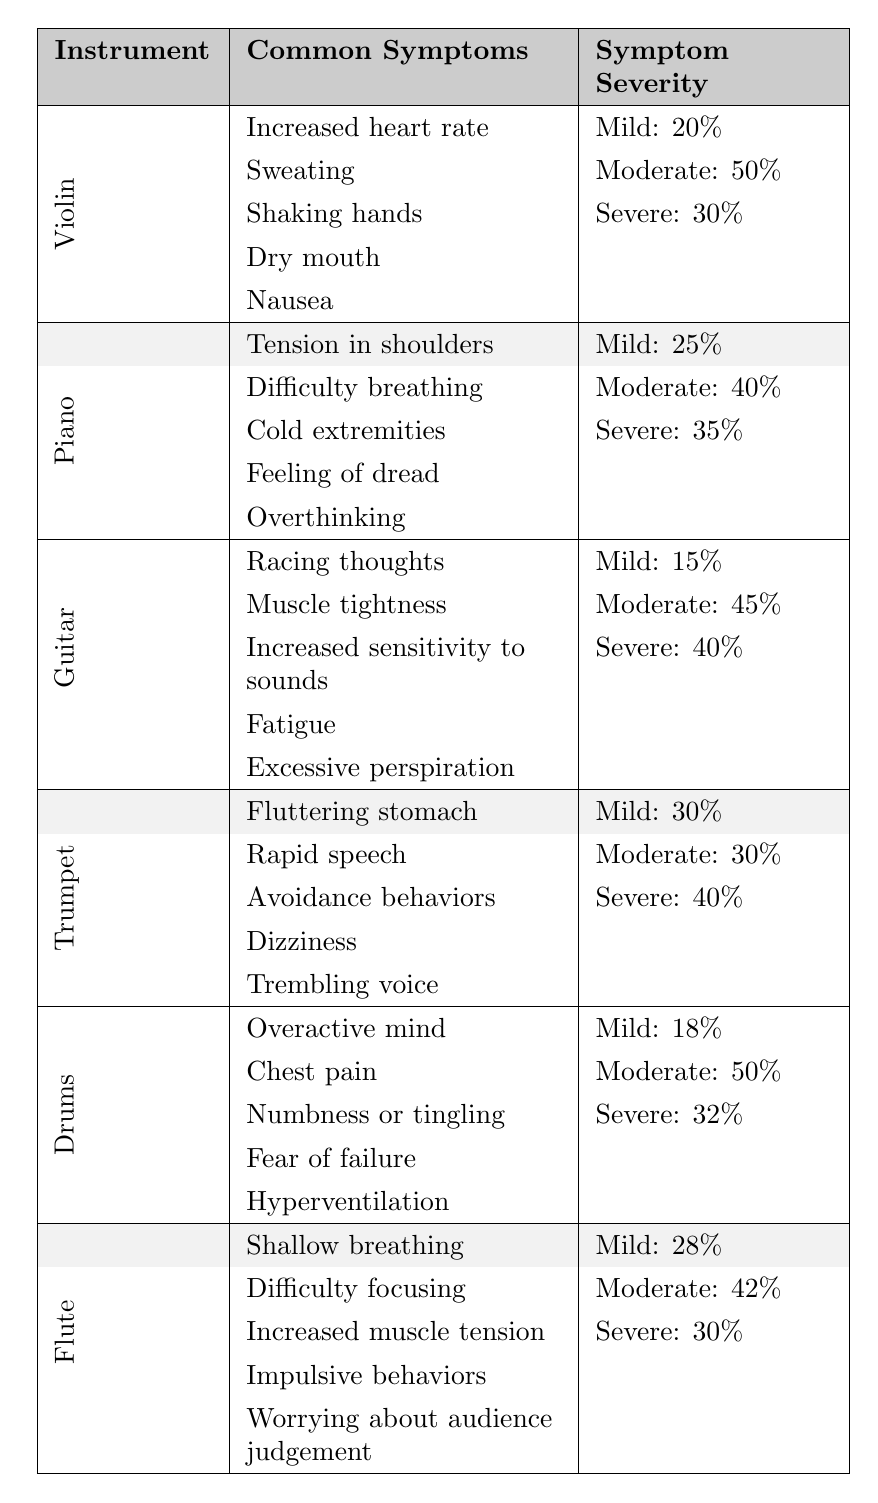What are the common symptoms of guitar players experiencing stage fright? Referring to the table, the symptoms listed for guitar players are racing thoughts, muscle tightness, increased sensitivity to sounds, fatigue, and excessive perspiration.
Answer: Racing thoughts, muscle tightness, increased sensitivity to sounds, fatigue, excessive perspiration Which instrument has the highest percentage of severe stage fright symptoms? By examining the severity data, trumpet, guitar, and drum players share severe symptoms with percentages of 40%, 40%, and 32% respectively, but trumpet has the highest among those listed, at 40%.
Answer: Trumpet How many different symptoms are reported for violin players? The table shows five symptoms listed under the violin category: increased heart rate, sweating, shaking hands, dry mouth, and nausea, indicating a total of five symptoms.
Answer: 5 Is it true that piano players report the least severe symptoms in comparison to other instruments? To determine this, we can compare the highest severe severity percentages of piano (35%) with the others: violin (30%), guitar (40%), trumpet (40%), drums (32%), and flute (30%). Piano does not report the least severe symptoms.
Answer: No What is the average percentage of mild symptoms reported across all instruments? To calculate the average, sum the mild percentages: 20 (violin) + 25 (piano) + 15 (guitar) + 30 (trumpet) + 18 (drums) + 28 (flute) = 136. Divide by 6 (number of instruments), so average = 136/6 = 22.67.
Answer: 22.67 Which instrument has the lowest percentage of mild symptoms? Looking at the percentages for mild symptoms, guitar has the lowest at 15% compared to violin (20%), piano (25%), trumpet (30%), drums (18%), and flute (28%).
Answer: Guitar What are the common symptoms shared by piano and drums players? The table indicates that piano players report tension in shoulders, difficulty breathing, cold extremities, feeling of dread, and overthinking, while drums players report overactive mind, chest pain, numbness or tingling, fear of failure, and hyperventilation. There are no common symptoms shared.
Answer: None What is the difference in the percentage of severe symptoms between trumpet and flute players? The severe percentage for trumpet is 40% and for flute it is 30%. The difference is calculated as 40% - 30% = 10%.
Answer: 10% 